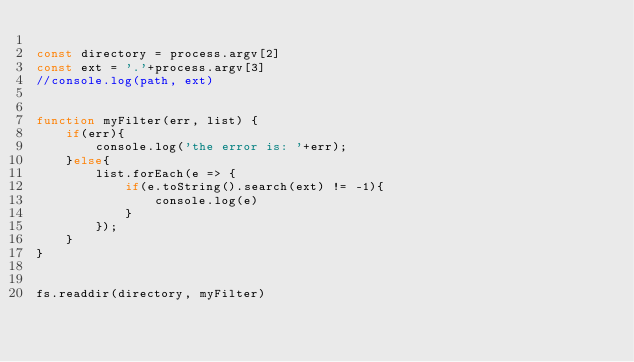Convert code to text. <code><loc_0><loc_0><loc_500><loc_500><_JavaScript_>
const directory = process.argv[2]
const ext = '.'+process.argv[3]
//console.log(path, ext)


function myFilter(err, list) {
    if(err){
        console.log('the error is: '+err);
    }else{        
        list.forEach(e => {
            if(e.toString().search(ext) != -1){
                console.log(e)
            }
        });
    }    
}


fs.readdir(directory, myFilter)</code> 